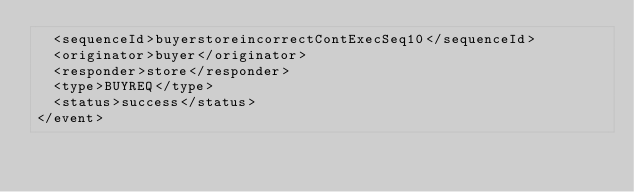<code> <loc_0><loc_0><loc_500><loc_500><_XML_>  <sequenceId>buyerstoreincorrectContExecSeq10</sequenceId>
  <originator>buyer</originator>
  <responder>store</responder>
  <type>BUYREQ</type>
  <status>success</status>
</event>
</code> 